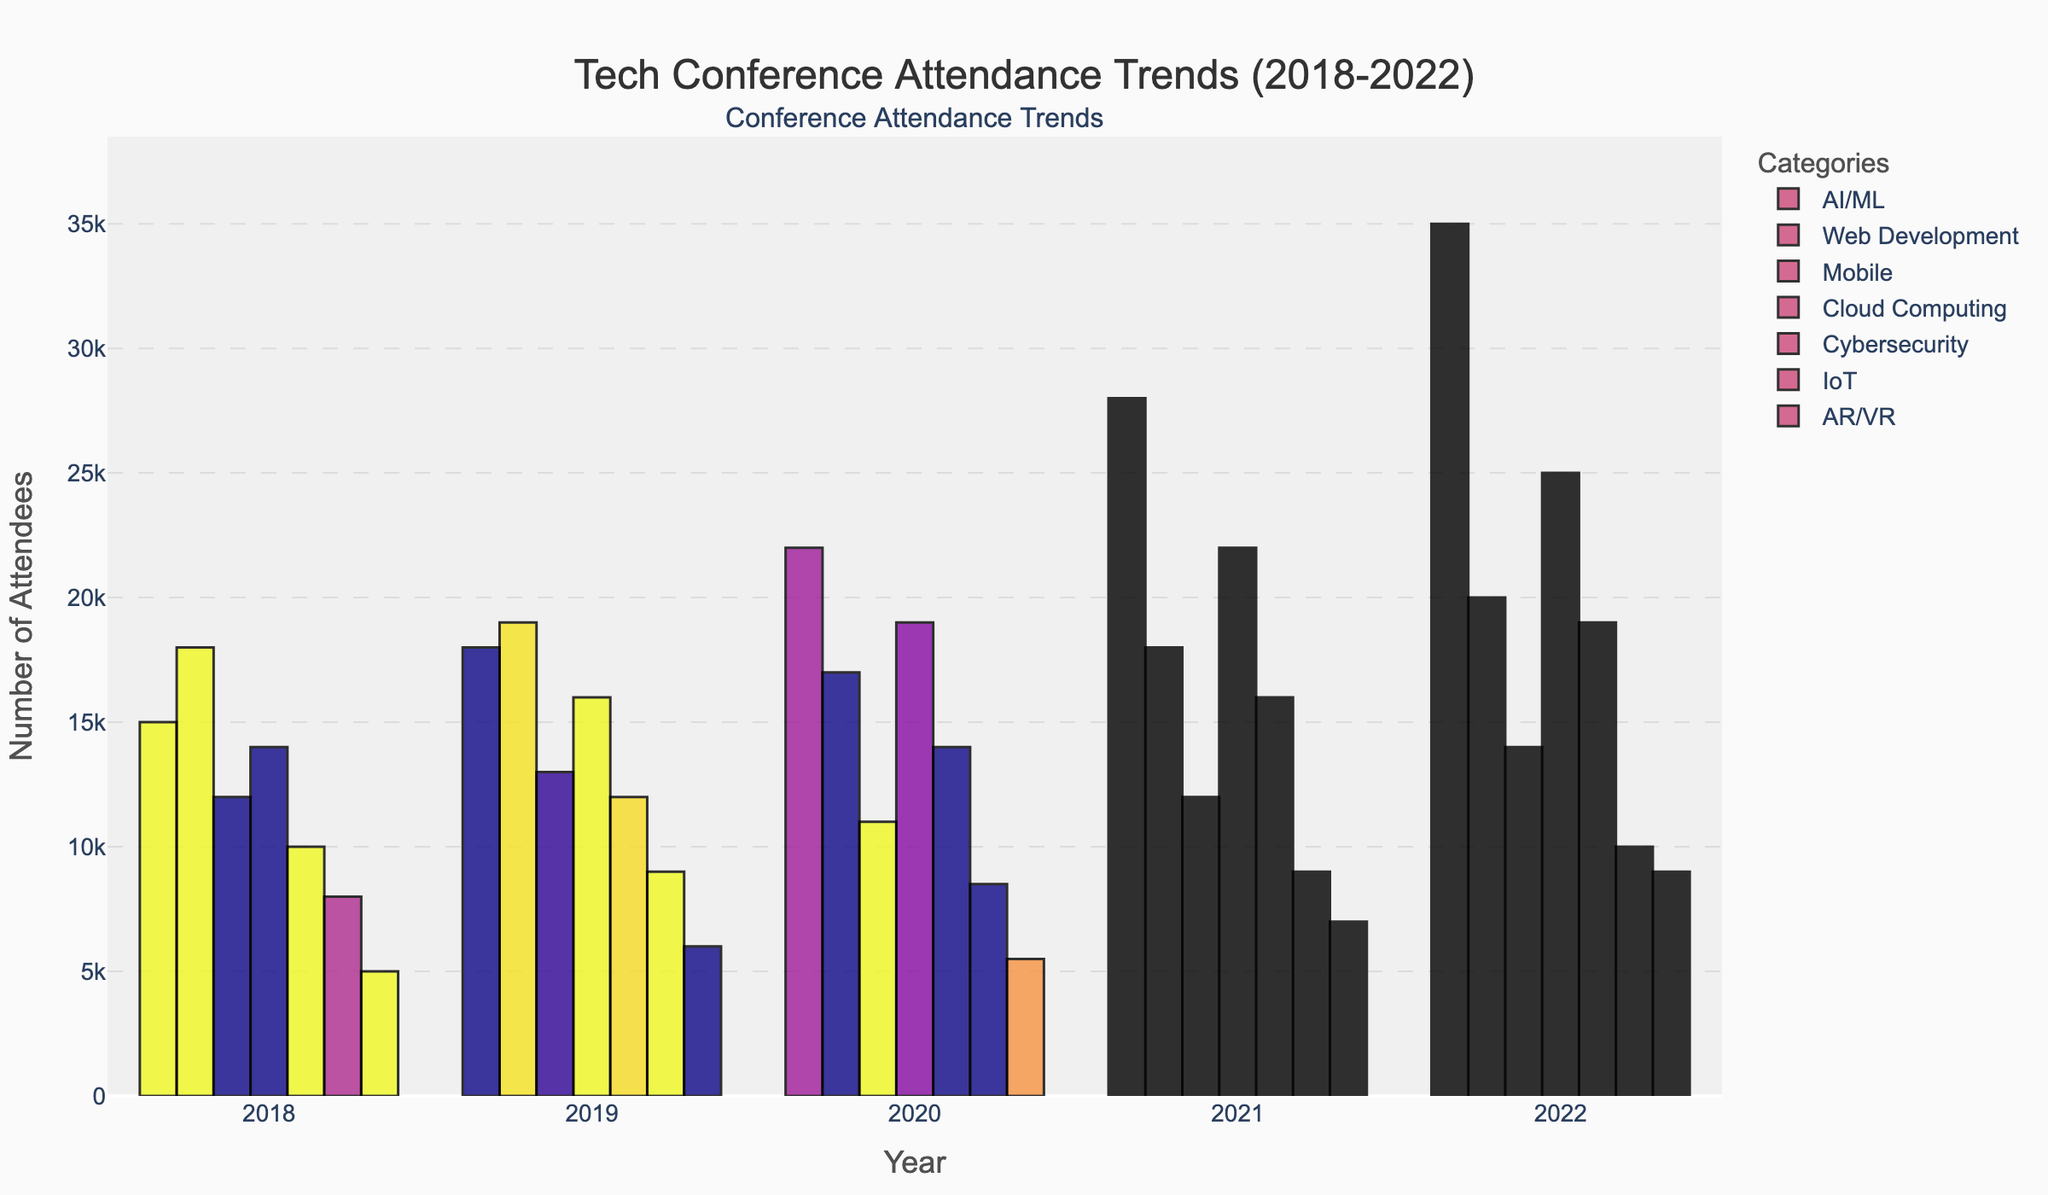What category saw the highest attendance in 2022? From the figure, examine the bars for the year 2022 and identify which category has the tallest bar, indicating the highest attendance.
Answer: AI/ML Which year experienced the most significant increase in AI/ML attendance compared to the previous year? Compare the height of the AI/ML bars across consecutive years to find the year with the largest increase. From 2021 to 2022, the AI/ML bar shows the largest increase.
Answer: 2022 What was the total attendance for Cybersecurity across all years? Sum the heights of the Cybersecurity bars for all years: 10000 (2018) + 12000 (2019) + 14000 (2020) + 16000 (2021) + 19000 (2022) = 71000 attendees.
Answer: 71000 Did Cloud Computing or Mobile have higher attendance in 2020, and by how much? Compare the heights of the Cloud Computing and Mobile bars for the year 2020. Cloud Computing has taller bars with 19000 attendees versus 11000 for Mobile. The difference is 19000 - 11000 = 8000 attendees.
Answer: Cloud Computing, by 8000 attendees Which category shows a declining trend in attendance over the 5 years? Look at the trend lines for each category. The Mobile category shows a general decline from 13000 in 2020 to 12000 in 2019 from its attendance.
Answer: Mobile What is the average attendance for IoT across the years? Sum the heights of the IoT bars for all years: 8000 (2018) + 9000 (2019) + 8500 (2020) + 9000 (2021) + 10000 (2022) = 44500. Then, divide by the number of years: 44500 / 5 = 8900 attendees.
Answer: 8900 Which category had the smallest increase in attendance from 2021 to 2022? Examine the height difference between the 2021 and 2022 bars for each category. AR/VR shows an increase from 7000 to 9000, which is the smallest compared to others.
Answer: AR/VR In which year did Web Development have the lowest attendance, and what was the value? Check the Web Development bars' heights across all years. The smallest bar, indicative of the lowest attendance, is in 2020 with 17000 attendees.
Answer: 2020, 17000 attendees By how much did the attendance for AR/VR increase from 2018 to 2022? Look at the AR/VR bar heights for 2018 and 2022. The increase is 9000 (2022) - 5000 (2018) = 4000 attendees.
Answer: 4000 